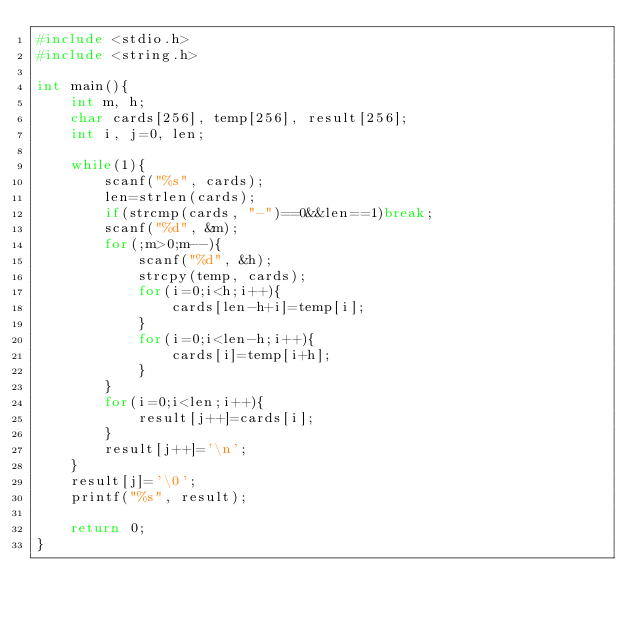Convert code to text. <code><loc_0><loc_0><loc_500><loc_500><_C_>#include <stdio.h>
#include <string.h>

int main(){
    int m, h;
    char cards[256], temp[256], result[256];
    int i, j=0, len;

    while(1){
        scanf("%s", cards);
        len=strlen(cards);
        if(strcmp(cards, "-")==0&&len==1)break;
        scanf("%d", &m);
        for(;m>0;m--){
            scanf("%d", &h);
            strcpy(temp, cards);
            for(i=0;i<h;i++){
                cards[len-h+i]=temp[i];
            }
            for(i=0;i<len-h;i++){
                cards[i]=temp[i+h];
            }
        }
        for(i=0;i<len;i++){
            result[j++]=cards[i];
        }
        result[j++]='\n';
    }
    result[j]='\0';
    printf("%s", result);

    return 0;
}
</code> 